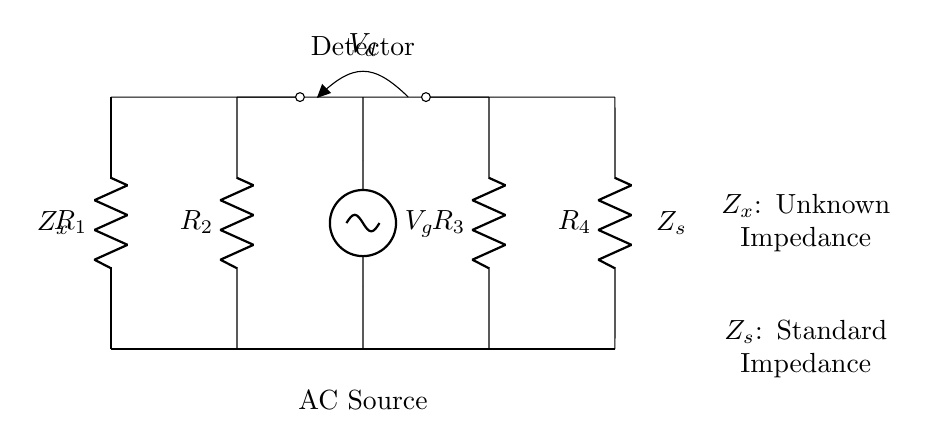What is the type of circuit depicted? The circuit is a bridge circuit specifically designed for impedance analysis. It has a configuration that permits precise measurements of the unknown impedance by comparing it to a known standard.
Answer: bridge circuit How many resistors are present in the circuit? There are four resistors labeled as R1, R2, R3, and R4. Each plays a role in balancing the circuit for impedance measurement.
Answer: four What is the function of the voltage source in this circuit? The voltage source provides an alternating current to energize the circuit, which is necessary for measuring impedance accurately in an AC bridge setup.
Answer: alternating current What component is used to measure the difference in voltage? The component used for measurement is the Detector, which assesses the voltage difference between two points in the circuit to help determine impedance.
Answer: Detector What does Zx represent in the circuit? Zx represents the unknown impedance that is being analyzed, which is critical to finding out the electrical properties of the circuit in a telecommunications context.
Answer: unknown impedance What is the purpose of comparing Zx with Zs? The purpose of comparing Zx (unknown impedance) with Zs (standard impedance) is to achieve a balance in the bridge circuit, which indicates the value of Zx when there is no voltage detected across the Detector.
Answer: achieve balance How is the output voltage of the bridge circuit indicated? The output voltage of the bridge circuit is indicated by the voltage difference across the Detector, which gives a direct measure of the balance condition and aids in calculating the unknown impedance.
Answer: voltage difference across the Detector 